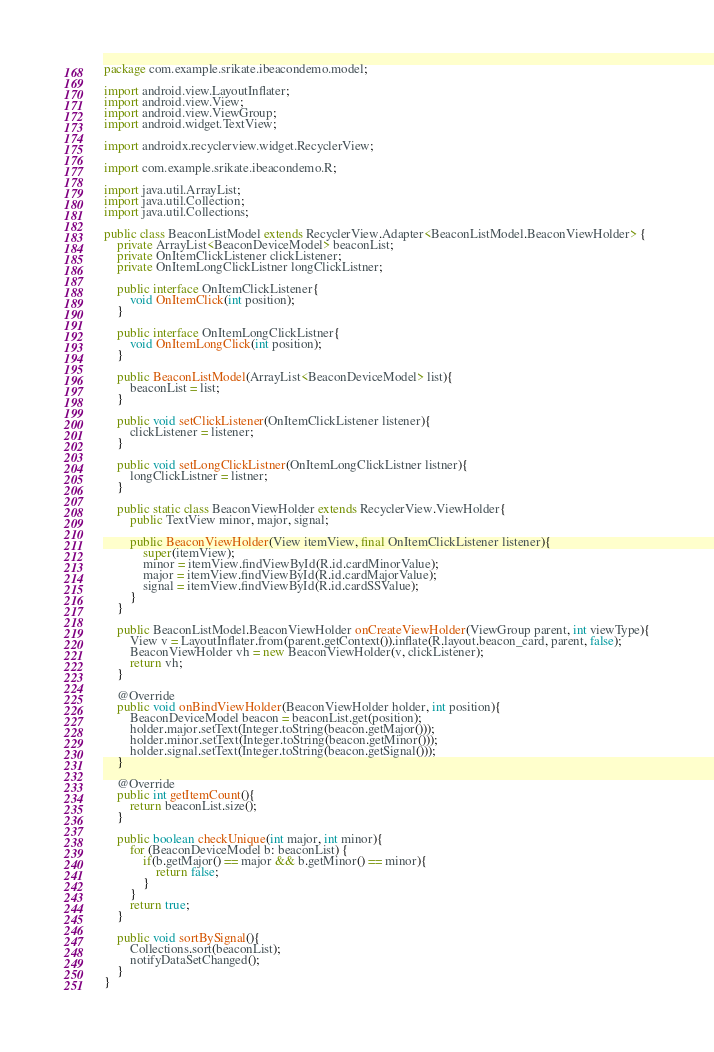<code> <loc_0><loc_0><loc_500><loc_500><_Java_>package com.example.srikate.ibeacondemo.model;

import android.view.LayoutInflater;
import android.view.View;
import android.view.ViewGroup;
import android.widget.TextView;

import androidx.recyclerview.widget.RecyclerView;

import com.example.srikate.ibeacondemo.R;

import java.util.ArrayList;
import java.util.Collection;
import java.util.Collections;

public class BeaconListModel extends RecyclerView.Adapter<BeaconListModel.BeaconViewHolder> {
    private ArrayList<BeaconDeviceModel> beaconList;
    private OnItemClickListener clickListener;
    private OnItemLongClickListner longClickListner;

    public interface OnItemClickListener{
        void OnItemClick(int position);
    }

    public interface OnItemLongClickListner{
        void OnItemLongClick(int position);
    }

    public BeaconListModel(ArrayList<BeaconDeviceModel> list){
        beaconList = list;
    }

    public void setClickListener(OnItemClickListener listener){
        clickListener = listener;
    }

    public void setLongClickListner(OnItemLongClickListner listner){
        longClickListner = listner;
    }

    public static class BeaconViewHolder extends RecyclerView.ViewHolder{
        public TextView minor, major, signal;

        public BeaconViewHolder(View itemView, final OnItemClickListener listener){
            super(itemView);
            minor = itemView.findViewById(R.id.cardMinorValue);
            major = itemView.findViewById(R.id.cardMajorValue);
            signal = itemView.findViewById(R.id.cardSSValue);
        }
    }

    public BeaconListModel.BeaconViewHolder onCreateViewHolder(ViewGroup parent, int viewType){
        View v = LayoutInflater.from(parent.getContext()).inflate(R.layout.beacon_card, parent, false);
        BeaconViewHolder vh = new BeaconViewHolder(v, clickListener);
        return vh;
    }

    @Override
    public void onBindViewHolder(BeaconViewHolder holder, int position){
        BeaconDeviceModel beacon = beaconList.get(position);
        holder.major.setText(Integer.toString(beacon.getMajor()));
        holder.minor.setText(Integer.toString(beacon.getMinor()));
        holder.signal.setText(Integer.toString(beacon.getSignal()));
    }

    @Override
    public int getItemCount(){
        return beaconList.size();
    }

    public boolean checkUnique(int major, int minor){
        for (BeaconDeviceModel b: beaconList) {
            if(b.getMajor() == major && b.getMinor() == minor){
                return false;
            }
        }
        return true;
    }

    public void sortBySignal(){
        Collections.sort(beaconList);
        notifyDataSetChanged();
    }
}
</code> 